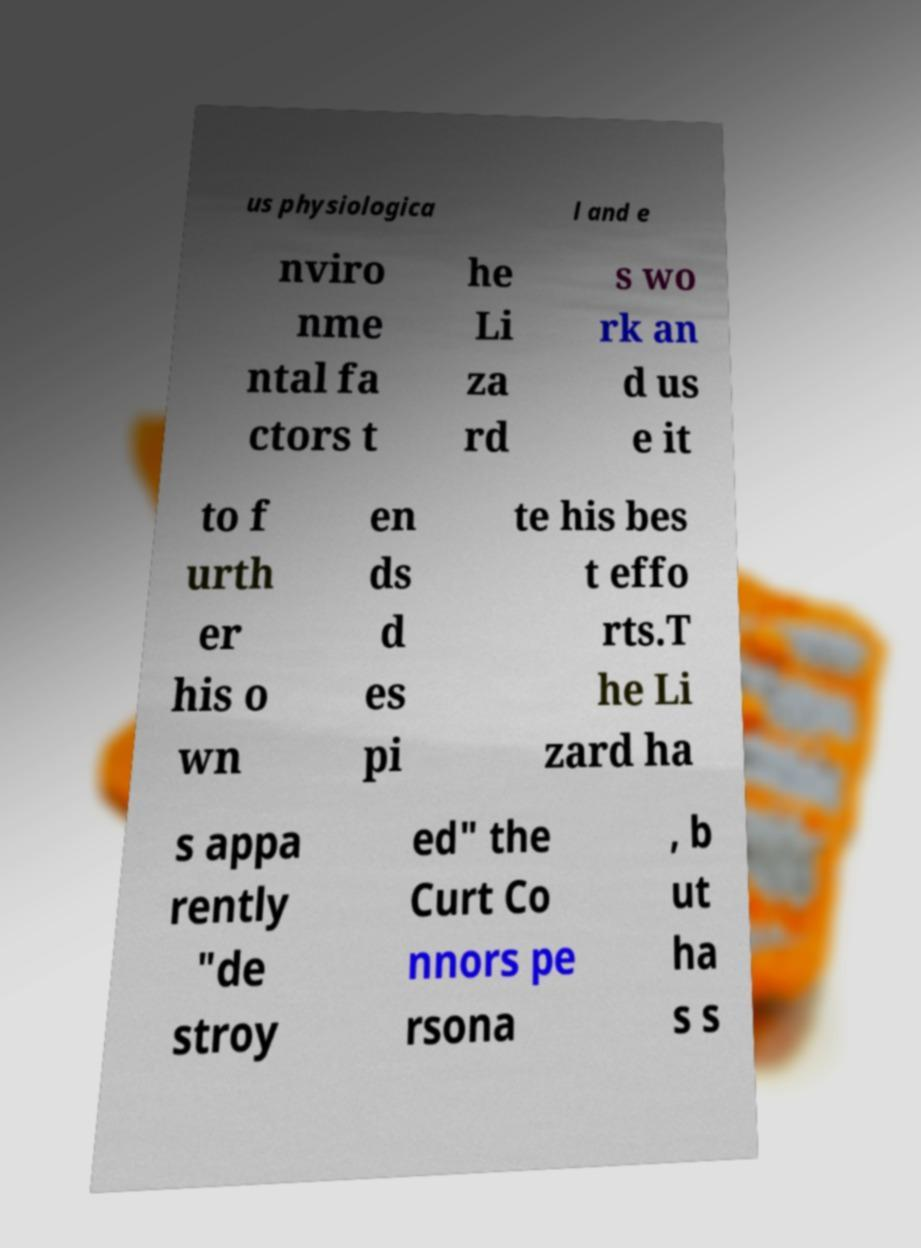Can you read and provide the text displayed in the image?This photo seems to have some interesting text. Can you extract and type it out for me? us physiologica l and e nviro nme ntal fa ctors t he Li za rd s wo rk an d us e it to f urth er his o wn en ds d es pi te his bes t effo rts.T he Li zard ha s appa rently "de stroy ed" the Curt Co nnors pe rsona , b ut ha s s 